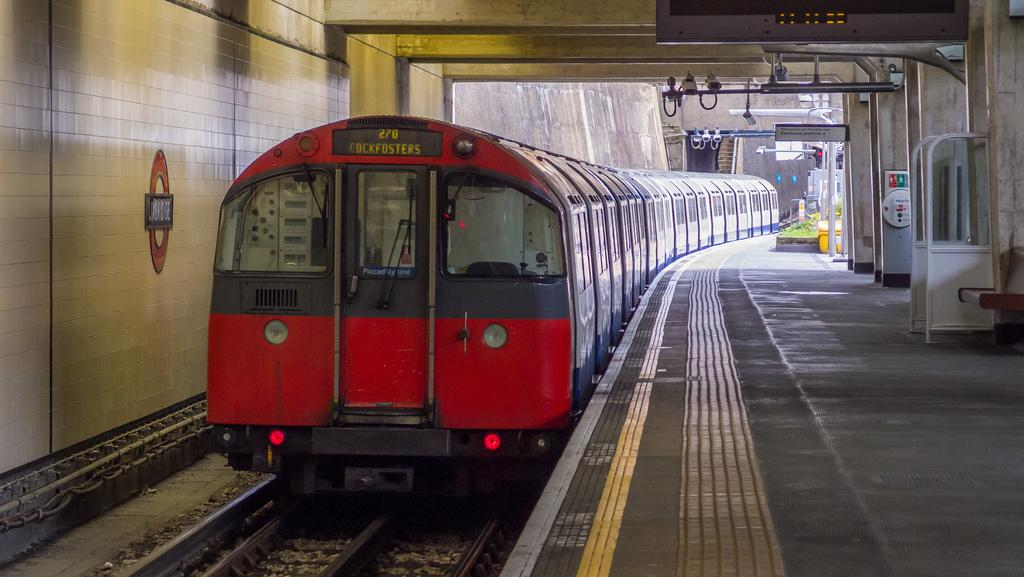What is the main subject of the image? The main subject of the image is a train. Where is the train located in the image? The train is on a track in the image. What else can be seen in the image besides the train? There is a platform, boards, and a bench on the right side of the image. How many chickens are laying eggs on the train in the image? There are no chickens or eggs present in the image. 